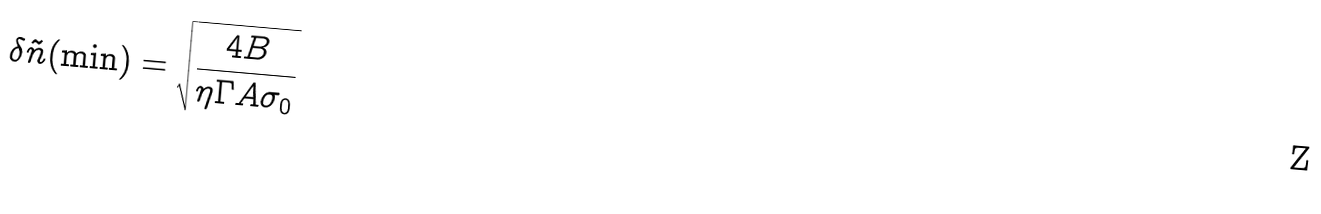Convert formula to latex. <formula><loc_0><loc_0><loc_500><loc_500>\delta \tilde { n } ( \min ) = \sqrt { \frac { 4 B } { \eta \Gamma A \sigma _ { 0 } } }</formula> 